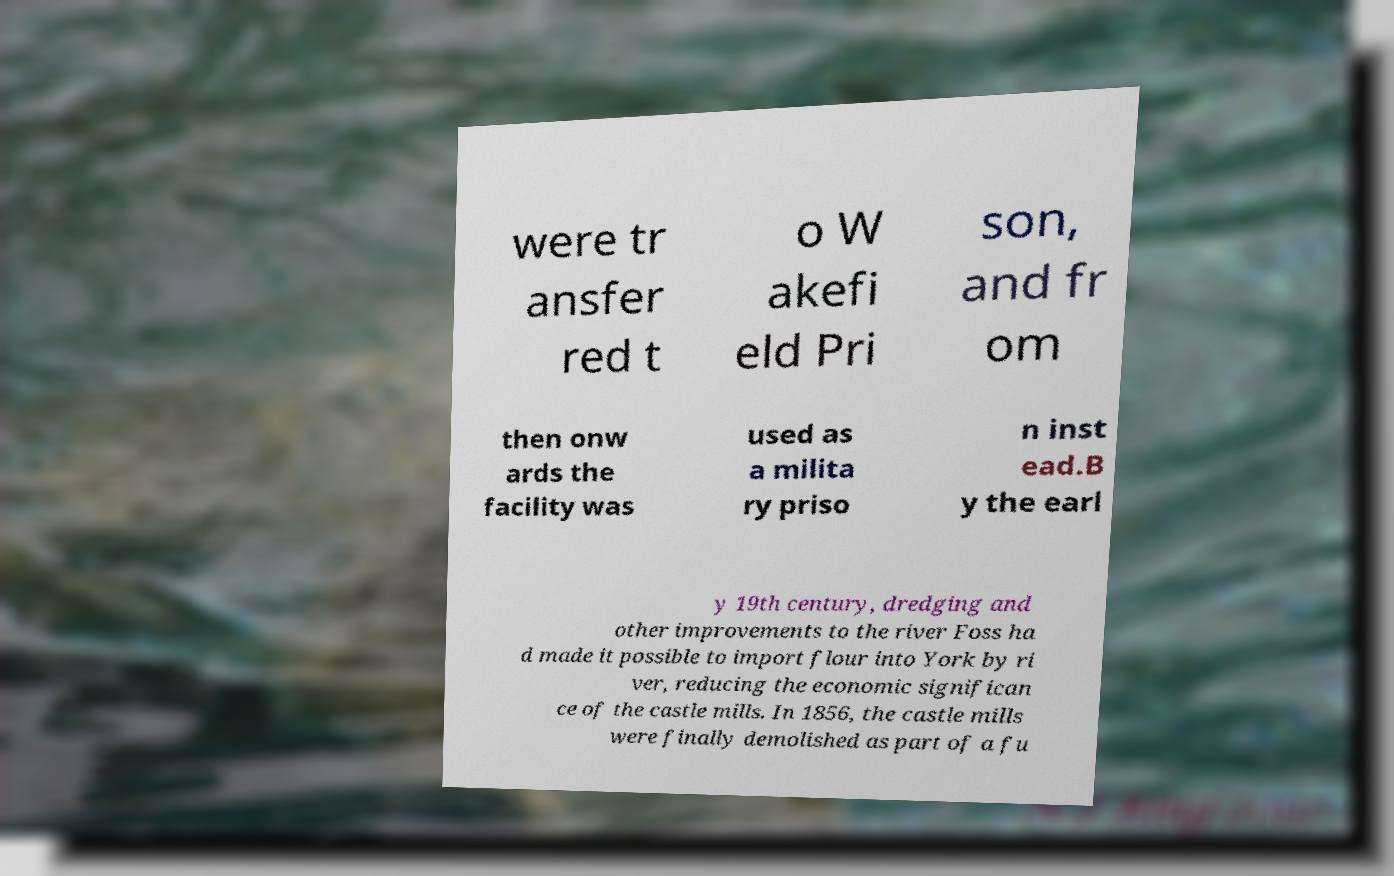Can you accurately transcribe the text from the provided image for me? were tr ansfer red t o W akefi eld Pri son, and fr om then onw ards the facility was used as a milita ry priso n inst ead.B y the earl y 19th century, dredging and other improvements to the river Foss ha d made it possible to import flour into York by ri ver, reducing the economic significan ce of the castle mills. In 1856, the castle mills were finally demolished as part of a fu 